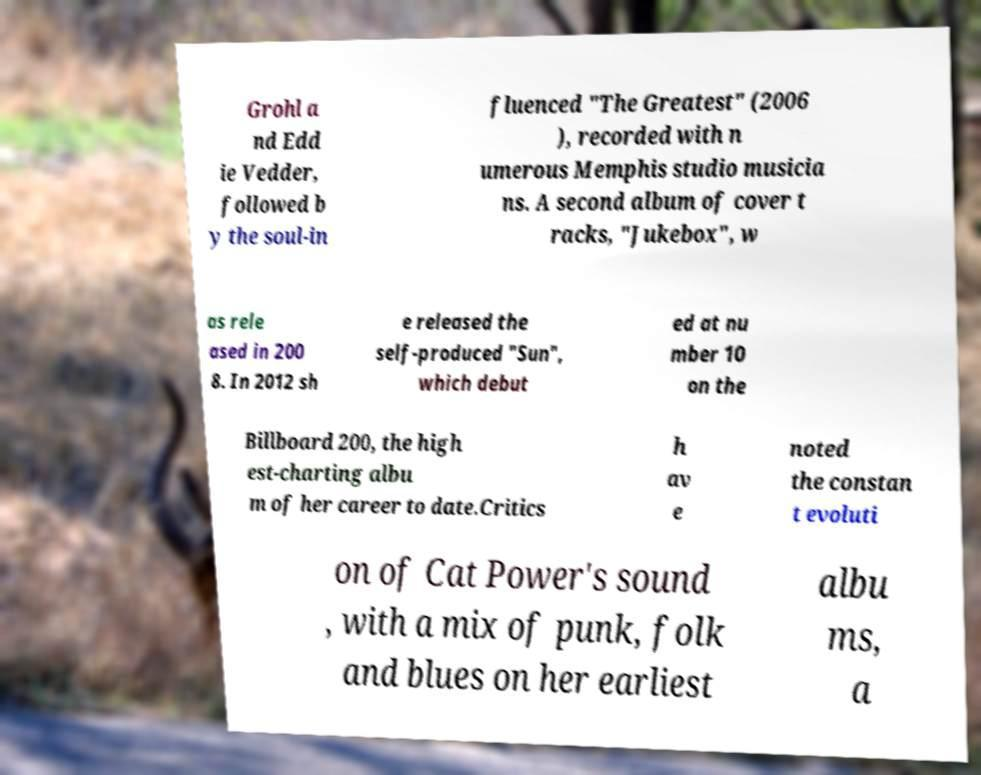What messages or text are displayed in this image? I need them in a readable, typed format. Grohl a nd Edd ie Vedder, followed b y the soul-in fluenced "The Greatest" (2006 ), recorded with n umerous Memphis studio musicia ns. A second album of cover t racks, "Jukebox", w as rele ased in 200 8. In 2012 sh e released the self-produced "Sun", which debut ed at nu mber 10 on the Billboard 200, the high est-charting albu m of her career to date.Critics h av e noted the constan t evoluti on of Cat Power's sound , with a mix of punk, folk and blues on her earliest albu ms, a 